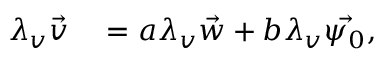<formula> <loc_0><loc_0><loc_500><loc_500>\begin{array} { r l } { \lambda _ { v } \vec { v } } & = a \lambda _ { v } \vec { w } + b \lambda _ { v } \vec { \psi _ { 0 } } , } \end{array}</formula> 